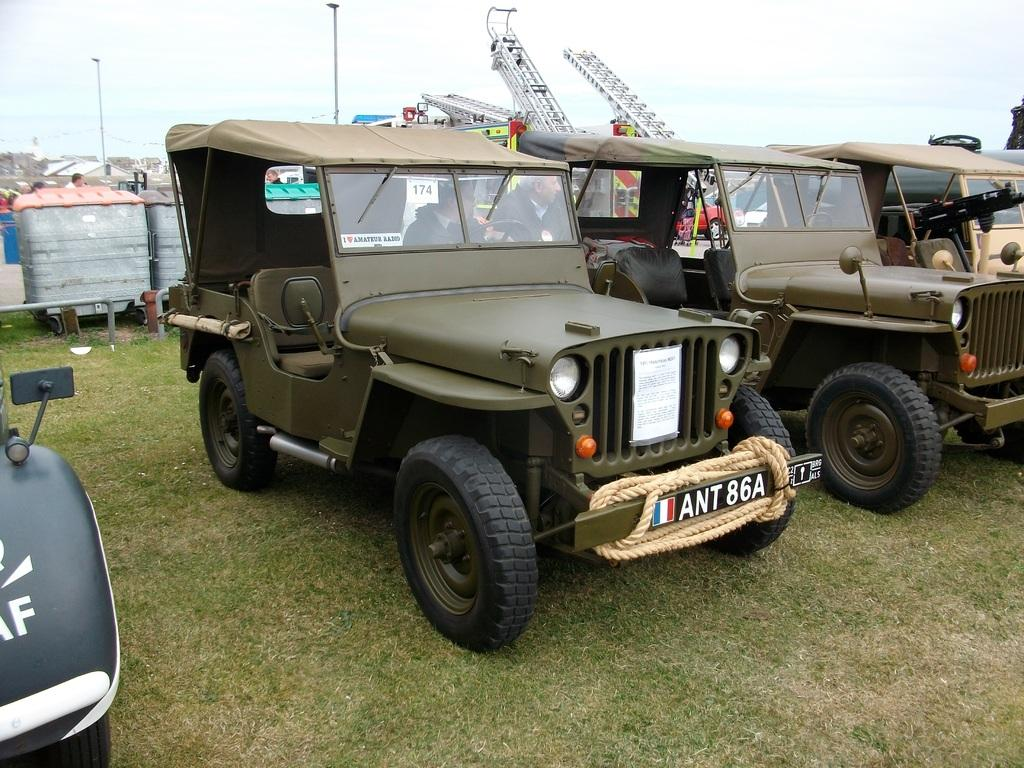What type of vegetation covers the land in the image? The land is covered with grass. What types of objects can be seen in the image? There are vehicles, a light pole, and a rope in the image. What is the relationship between the two people in the image? The two people are between the vehicles. How many cherries are hanging from the light pole in the image? There are no cherries present in the image. 